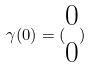<formula> <loc_0><loc_0><loc_500><loc_500>\gamma ( 0 ) = ( \begin{matrix} 0 \\ 0 \end{matrix} )</formula> 